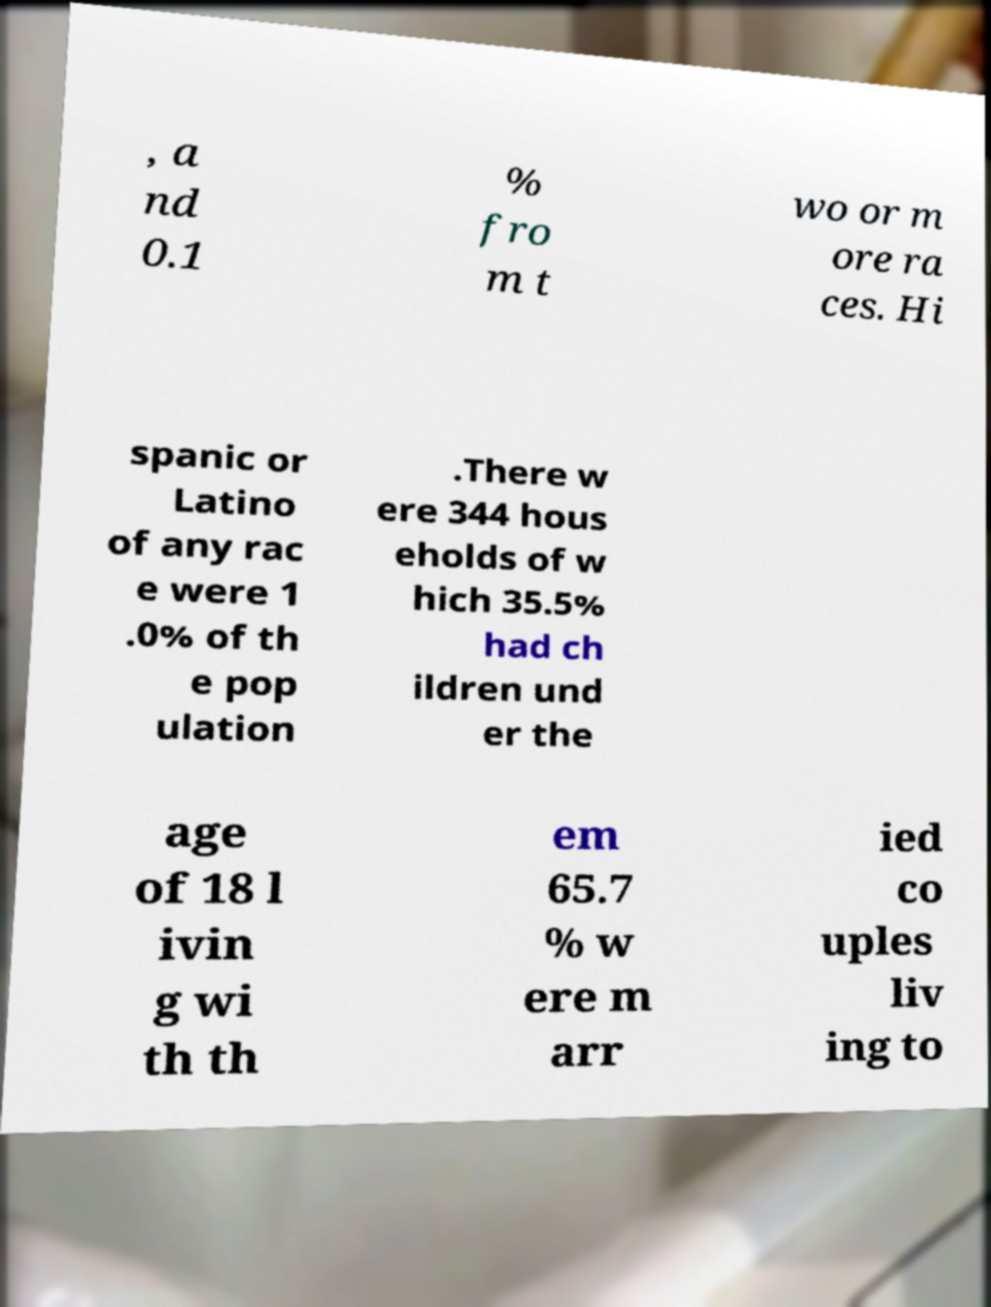Can you accurately transcribe the text from the provided image for me? , a nd 0.1 % fro m t wo or m ore ra ces. Hi spanic or Latino of any rac e were 1 .0% of th e pop ulation .There w ere 344 hous eholds of w hich 35.5% had ch ildren und er the age of 18 l ivin g wi th th em 65.7 % w ere m arr ied co uples liv ing to 